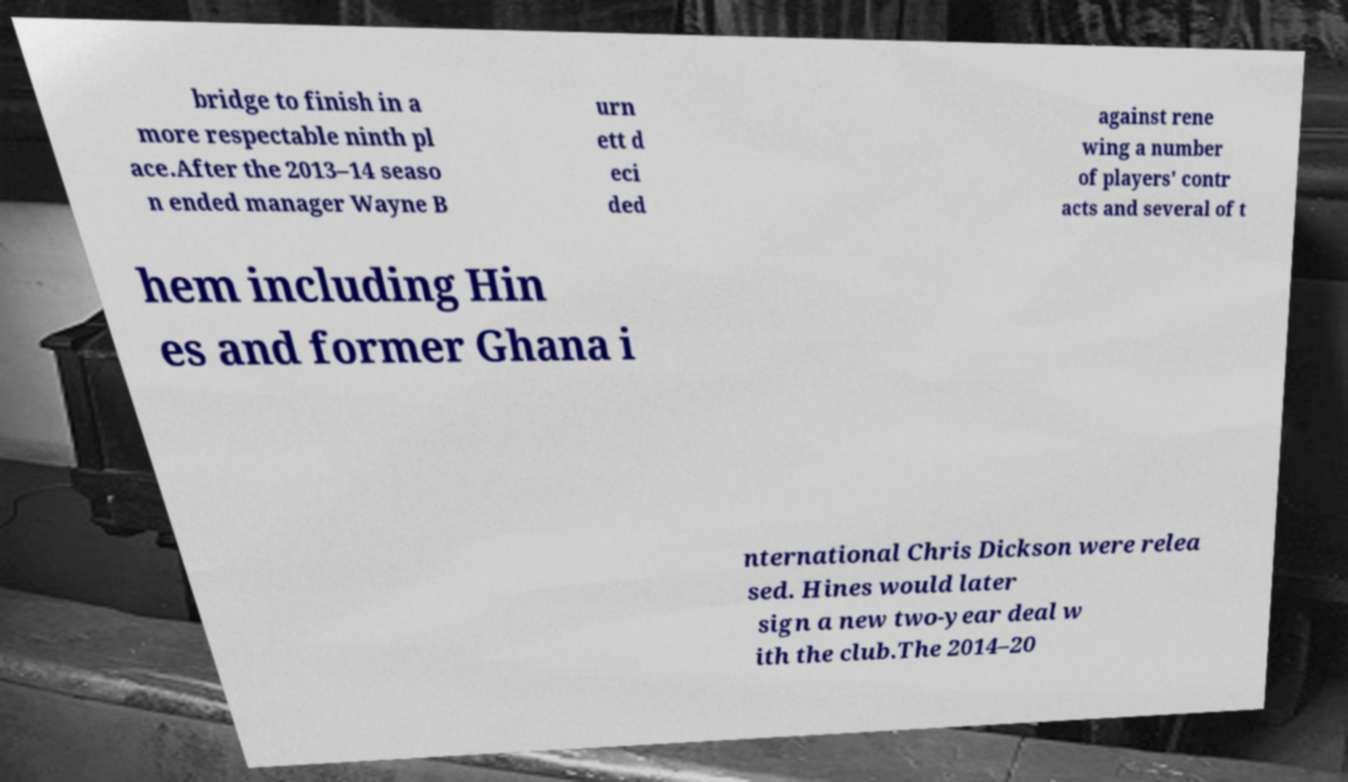Could you extract and type out the text from this image? bridge to finish in a more respectable ninth pl ace.After the 2013–14 seaso n ended manager Wayne B urn ett d eci ded against rene wing a number of players' contr acts and several of t hem including Hin es and former Ghana i nternational Chris Dickson were relea sed. Hines would later sign a new two-year deal w ith the club.The 2014–20 